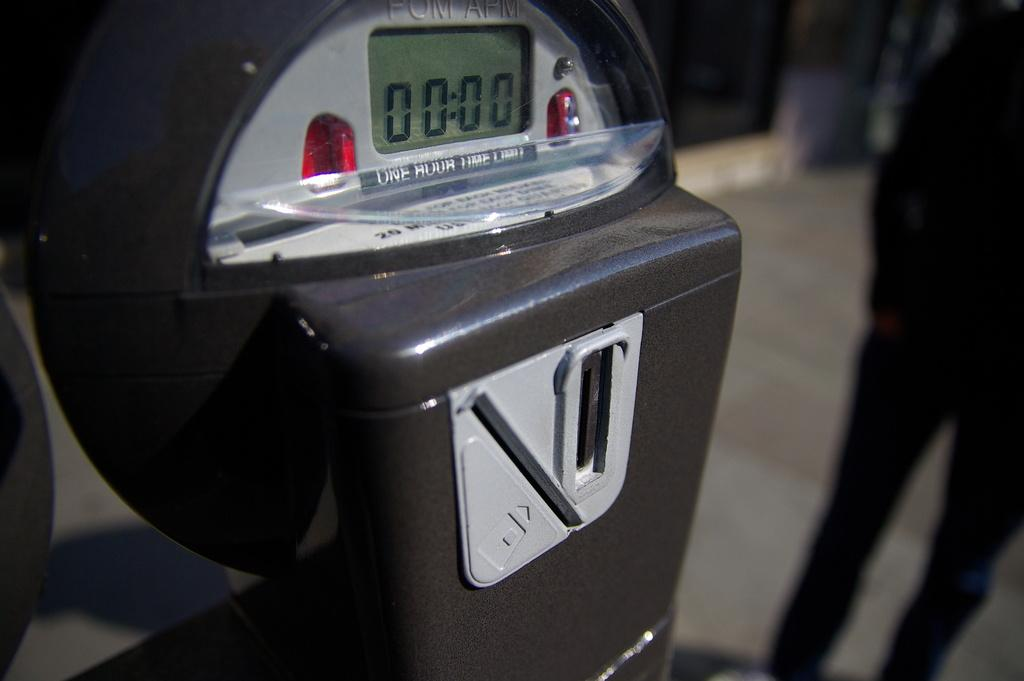Provide a one-sentence caption for the provided image. A black parking meter claims a one hour limit. 